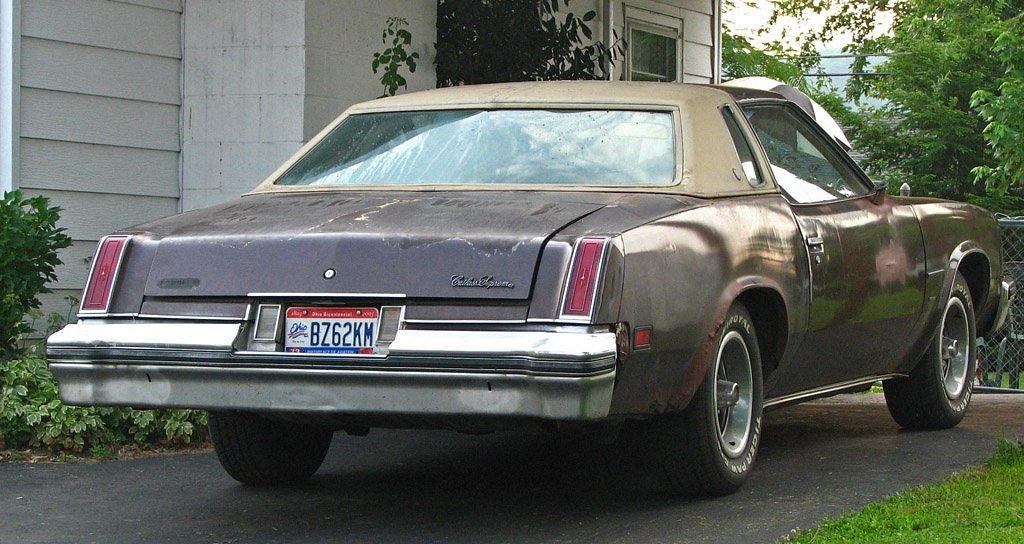What is the main subject of the image? There is a car in the image. What can be seen in the background of the image? There is a house and trees in the background of the image. How many books are visible on the car's dashboard in the image? There are no books visible on the car's dashboard in the image. Can you hear the sound of bells ringing in the image? There is no mention of bells or any sound in the image, so it cannot be determined from the image alone. 